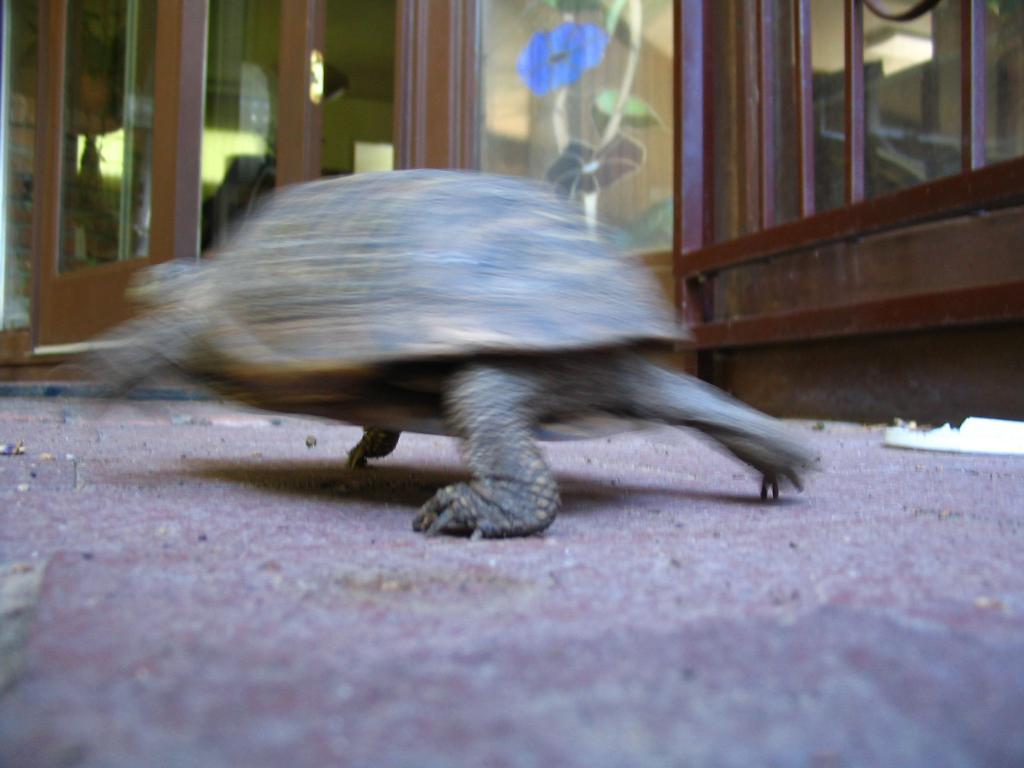What is the main subject in the center of the image? There is a tortoise in the center of the image. What can be seen in the background of the image? There are glass doors, plants, and lights in the background of the image. What is at the bottom of the image? There is a walkway at the bottom of the image. How many eyes can be seen on the box in the image? There is no box present in the image, so it is not possible to determine the number of eyes on a box. 